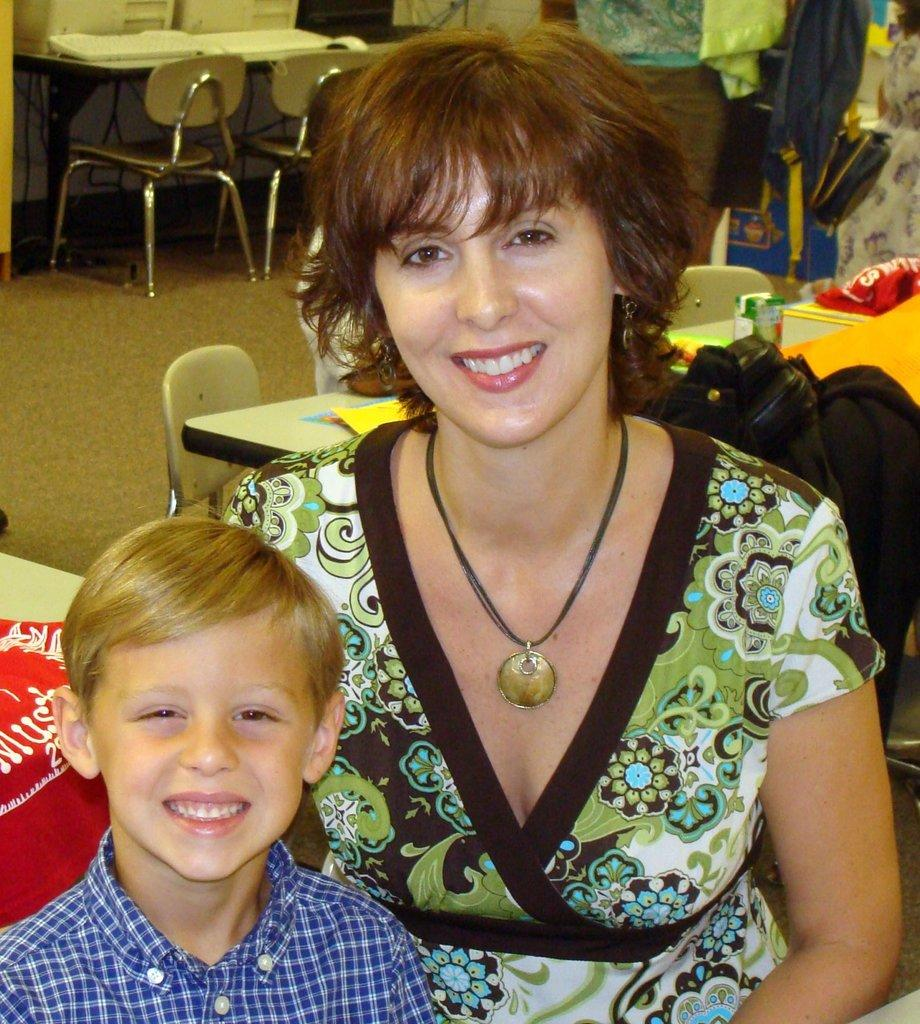Who is present in the image? There is a woman and a boy in the image. What are the expressions on their faces? Both the woman and the boy are smiling in the image. What type of furniture is visible in the image? There is a table and chairs in the image. What is the surface beneath the furniture? There is a floor visible in the image. What type of cactus can be seen on the table in the image? There is no cactus present on the table in the image. How does the taste of the air in the image feel to the woman and the boy? The taste of the air cannot be determined from the image, as taste is not a sense that can be perceived visually. 